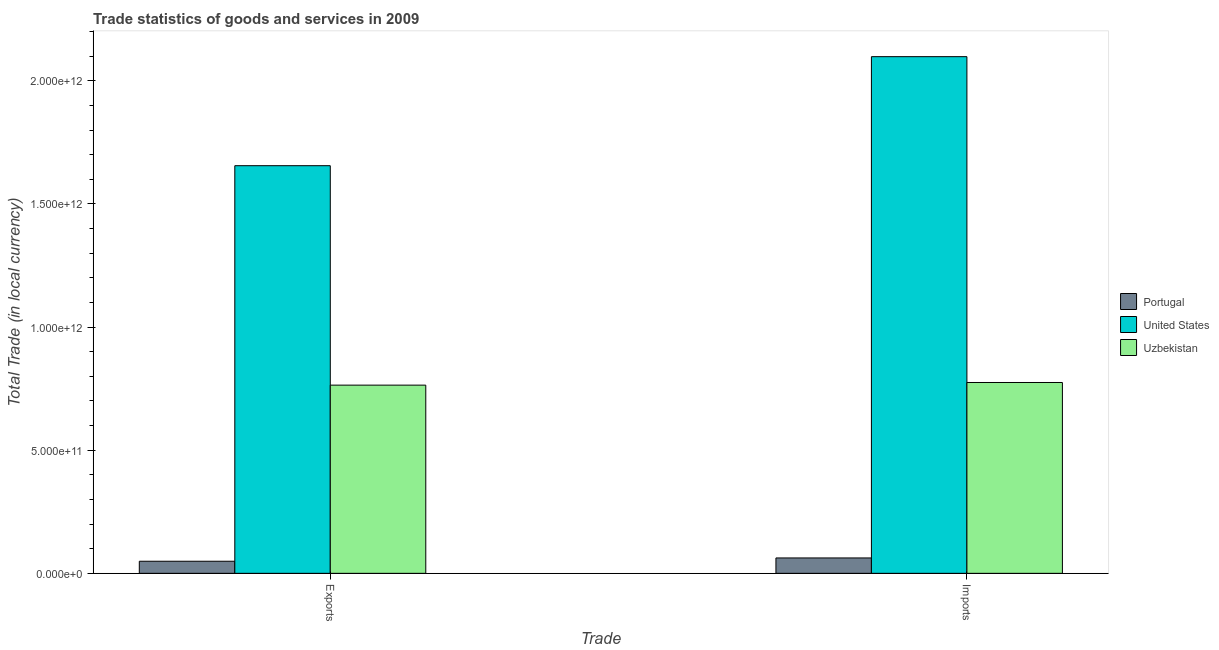How many different coloured bars are there?
Provide a succinct answer. 3. Are the number of bars per tick equal to the number of legend labels?
Your response must be concise. Yes. Are the number of bars on each tick of the X-axis equal?
Offer a very short reply. Yes. What is the label of the 1st group of bars from the left?
Ensure brevity in your answer.  Exports. What is the imports of goods and services in Uzbekistan?
Provide a short and direct response. 7.75e+11. Across all countries, what is the maximum export of goods and services?
Your answer should be compact. 1.66e+12. Across all countries, what is the minimum export of goods and services?
Give a very brief answer. 4.91e+1. In which country was the export of goods and services maximum?
Make the answer very short. United States. What is the total imports of goods and services in the graph?
Your response must be concise. 2.94e+12. What is the difference between the imports of goods and services in Uzbekistan and that in United States?
Your answer should be compact. -1.32e+12. What is the difference between the export of goods and services in Portugal and the imports of goods and services in United States?
Offer a terse response. -2.05e+12. What is the average imports of goods and services per country?
Provide a short and direct response. 9.79e+11. What is the difference between the export of goods and services and imports of goods and services in United States?
Offer a very short reply. -4.43e+11. In how many countries, is the imports of goods and services greater than 1300000000000 LCU?
Make the answer very short. 1. What is the ratio of the imports of goods and services in Uzbekistan to that in United States?
Provide a short and direct response. 0.37. Is the imports of goods and services in Portugal less than that in United States?
Offer a very short reply. Yes. In how many countries, is the export of goods and services greater than the average export of goods and services taken over all countries?
Your response must be concise. 1. What does the 3rd bar from the left in Imports represents?
Offer a very short reply. Uzbekistan. What does the 2nd bar from the right in Exports represents?
Give a very brief answer. United States. Are all the bars in the graph horizontal?
Your answer should be compact. No. What is the difference between two consecutive major ticks on the Y-axis?
Keep it short and to the point. 5.00e+11. Are the values on the major ticks of Y-axis written in scientific E-notation?
Offer a terse response. Yes. Does the graph contain any zero values?
Your answer should be compact. No. Where does the legend appear in the graph?
Keep it short and to the point. Center right. How are the legend labels stacked?
Keep it short and to the point. Vertical. What is the title of the graph?
Offer a terse response. Trade statistics of goods and services in 2009. What is the label or title of the X-axis?
Make the answer very short. Trade. What is the label or title of the Y-axis?
Provide a succinct answer. Total Trade (in local currency). What is the Total Trade (in local currency) in Portugal in Exports?
Your answer should be compact. 4.91e+1. What is the Total Trade (in local currency) in United States in Exports?
Ensure brevity in your answer.  1.66e+12. What is the Total Trade (in local currency) of Uzbekistan in Exports?
Provide a short and direct response. 7.64e+11. What is the Total Trade (in local currency) in Portugal in Imports?
Offer a terse response. 6.25e+1. What is the Total Trade (in local currency) of United States in Imports?
Make the answer very short. 2.10e+12. What is the Total Trade (in local currency) in Uzbekistan in Imports?
Keep it short and to the point. 7.75e+11. Across all Trade, what is the maximum Total Trade (in local currency) of Portugal?
Your response must be concise. 6.25e+1. Across all Trade, what is the maximum Total Trade (in local currency) in United States?
Keep it short and to the point. 2.10e+12. Across all Trade, what is the maximum Total Trade (in local currency) of Uzbekistan?
Your response must be concise. 7.75e+11. Across all Trade, what is the minimum Total Trade (in local currency) of Portugal?
Provide a succinct answer. 4.91e+1. Across all Trade, what is the minimum Total Trade (in local currency) in United States?
Your answer should be compact. 1.66e+12. Across all Trade, what is the minimum Total Trade (in local currency) of Uzbekistan?
Ensure brevity in your answer.  7.64e+11. What is the total Total Trade (in local currency) in Portugal in the graph?
Make the answer very short. 1.12e+11. What is the total Total Trade (in local currency) in United States in the graph?
Make the answer very short. 3.75e+12. What is the total Total Trade (in local currency) in Uzbekistan in the graph?
Provide a succinct answer. 1.54e+12. What is the difference between the Total Trade (in local currency) of Portugal in Exports and that in Imports?
Provide a short and direct response. -1.34e+1. What is the difference between the Total Trade (in local currency) of United States in Exports and that in Imports?
Your answer should be compact. -4.43e+11. What is the difference between the Total Trade (in local currency) of Uzbekistan in Exports and that in Imports?
Offer a very short reply. -1.07e+1. What is the difference between the Total Trade (in local currency) in Portugal in Exports and the Total Trade (in local currency) in United States in Imports?
Your response must be concise. -2.05e+12. What is the difference between the Total Trade (in local currency) in Portugal in Exports and the Total Trade (in local currency) in Uzbekistan in Imports?
Offer a terse response. -7.26e+11. What is the difference between the Total Trade (in local currency) in United States in Exports and the Total Trade (in local currency) in Uzbekistan in Imports?
Offer a very short reply. 8.80e+11. What is the average Total Trade (in local currency) of Portugal per Trade?
Offer a terse response. 5.58e+1. What is the average Total Trade (in local currency) in United States per Trade?
Provide a short and direct response. 1.88e+12. What is the average Total Trade (in local currency) of Uzbekistan per Trade?
Offer a very short reply. 7.70e+11. What is the difference between the Total Trade (in local currency) in Portugal and Total Trade (in local currency) in United States in Exports?
Your answer should be very brief. -1.61e+12. What is the difference between the Total Trade (in local currency) in Portugal and Total Trade (in local currency) in Uzbekistan in Exports?
Offer a very short reply. -7.15e+11. What is the difference between the Total Trade (in local currency) in United States and Total Trade (in local currency) in Uzbekistan in Exports?
Provide a succinct answer. 8.91e+11. What is the difference between the Total Trade (in local currency) of Portugal and Total Trade (in local currency) of United States in Imports?
Your answer should be very brief. -2.04e+12. What is the difference between the Total Trade (in local currency) of Portugal and Total Trade (in local currency) of Uzbekistan in Imports?
Offer a very short reply. -7.13e+11. What is the difference between the Total Trade (in local currency) in United States and Total Trade (in local currency) in Uzbekistan in Imports?
Make the answer very short. 1.32e+12. What is the ratio of the Total Trade (in local currency) of Portugal in Exports to that in Imports?
Your response must be concise. 0.79. What is the ratio of the Total Trade (in local currency) of United States in Exports to that in Imports?
Your answer should be compact. 0.79. What is the ratio of the Total Trade (in local currency) of Uzbekistan in Exports to that in Imports?
Provide a succinct answer. 0.99. What is the difference between the highest and the second highest Total Trade (in local currency) in Portugal?
Offer a terse response. 1.34e+1. What is the difference between the highest and the second highest Total Trade (in local currency) in United States?
Ensure brevity in your answer.  4.43e+11. What is the difference between the highest and the second highest Total Trade (in local currency) of Uzbekistan?
Your response must be concise. 1.07e+1. What is the difference between the highest and the lowest Total Trade (in local currency) in Portugal?
Provide a succinct answer. 1.34e+1. What is the difference between the highest and the lowest Total Trade (in local currency) of United States?
Your response must be concise. 4.43e+11. What is the difference between the highest and the lowest Total Trade (in local currency) of Uzbekistan?
Your answer should be compact. 1.07e+1. 